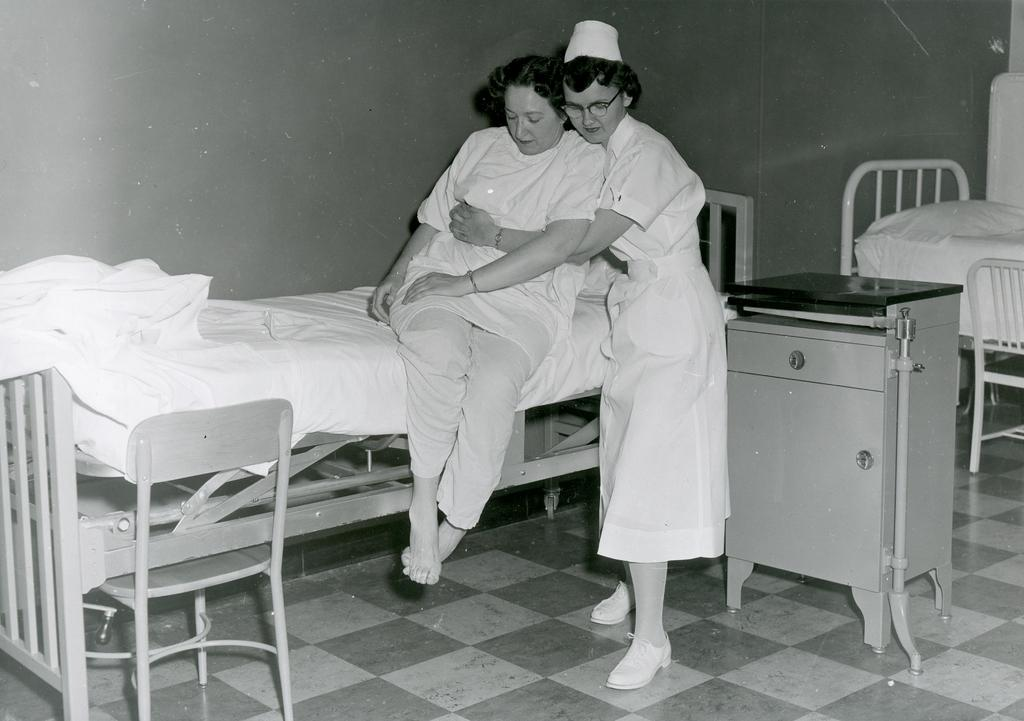How many women are in the image? There are two women in the image. What are the positions of the women in the image? One woman is sitting on the bed, and the other woman is standing. What can be seen in the background of the image? There is a wall, beds, a blanket, a table, chairs, and a pillow in the background of the image. What type of wool is being used by the army in the image? There is no army or wool present in the image. What is the back of the pillow like in the image? The provided facts do not mention the back of the pillow, only that there is a pillow in the background of the image. 